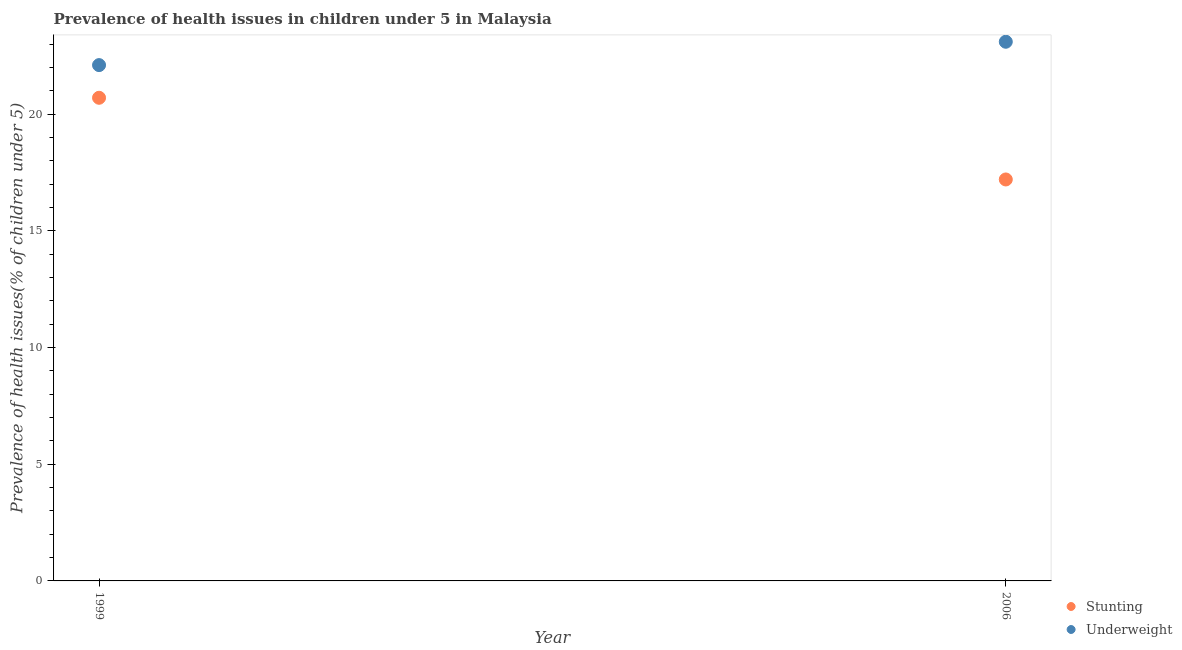How many different coloured dotlines are there?
Offer a terse response. 2. Is the number of dotlines equal to the number of legend labels?
Your response must be concise. Yes. What is the percentage of underweight children in 2006?
Offer a terse response. 23.1. Across all years, what is the maximum percentage of underweight children?
Ensure brevity in your answer.  23.1. Across all years, what is the minimum percentage of stunted children?
Give a very brief answer. 17.2. In which year was the percentage of underweight children maximum?
Provide a short and direct response. 2006. What is the total percentage of stunted children in the graph?
Your response must be concise. 37.9. What is the difference between the percentage of underweight children in 1999 and that in 2006?
Make the answer very short. -1. What is the difference between the percentage of stunted children in 2006 and the percentage of underweight children in 1999?
Ensure brevity in your answer.  -4.9. What is the average percentage of stunted children per year?
Offer a very short reply. 18.95. In the year 1999, what is the difference between the percentage of underweight children and percentage of stunted children?
Offer a very short reply. 1.4. In how many years, is the percentage of stunted children greater than 8 %?
Provide a succinct answer. 2. What is the ratio of the percentage of stunted children in 1999 to that in 2006?
Provide a short and direct response. 1.2. Is the percentage of stunted children in 1999 less than that in 2006?
Make the answer very short. No. In how many years, is the percentage of underweight children greater than the average percentage of underweight children taken over all years?
Offer a very short reply. 1. How many dotlines are there?
Provide a succinct answer. 2. Are the values on the major ticks of Y-axis written in scientific E-notation?
Your response must be concise. No. Does the graph contain grids?
Offer a terse response. No. Where does the legend appear in the graph?
Offer a terse response. Bottom right. How many legend labels are there?
Offer a very short reply. 2. How are the legend labels stacked?
Your answer should be very brief. Vertical. What is the title of the graph?
Your response must be concise. Prevalence of health issues in children under 5 in Malaysia. What is the label or title of the Y-axis?
Your response must be concise. Prevalence of health issues(% of children under 5). What is the Prevalence of health issues(% of children under 5) in Stunting in 1999?
Provide a short and direct response. 20.7. What is the Prevalence of health issues(% of children under 5) in Underweight in 1999?
Ensure brevity in your answer.  22.1. What is the Prevalence of health issues(% of children under 5) of Stunting in 2006?
Provide a succinct answer. 17.2. What is the Prevalence of health issues(% of children under 5) in Underweight in 2006?
Offer a terse response. 23.1. Across all years, what is the maximum Prevalence of health issues(% of children under 5) of Stunting?
Make the answer very short. 20.7. Across all years, what is the maximum Prevalence of health issues(% of children under 5) in Underweight?
Provide a short and direct response. 23.1. Across all years, what is the minimum Prevalence of health issues(% of children under 5) in Stunting?
Make the answer very short. 17.2. Across all years, what is the minimum Prevalence of health issues(% of children under 5) of Underweight?
Your answer should be very brief. 22.1. What is the total Prevalence of health issues(% of children under 5) of Stunting in the graph?
Provide a succinct answer. 37.9. What is the total Prevalence of health issues(% of children under 5) of Underweight in the graph?
Your answer should be compact. 45.2. What is the difference between the Prevalence of health issues(% of children under 5) in Underweight in 1999 and that in 2006?
Make the answer very short. -1. What is the average Prevalence of health issues(% of children under 5) of Stunting per year?
Provide a short and direct response. 18.95. What is the average Prevalence of health issues(% of children under 5) of Underweight per year?
Make the answer very short. 22.6. In the year 2006, what is the difference between the Prevalence of health issues(% of children under 5) in Stunting and Prevalence of health issues(% of children under 5) in Underweight?
Give a very brief answer. -5.9. What is the ratio of the Prevalence of health issues(% of children under 5) of Stunting in 1999 to that in 2006?
Your answer should be very brief. 1.2. What is the ratio of the Prevalence of health issues(% of children under 5) of Underweight in 1999 to that in 2006?
Offer a very short reply. 0.96. What is the difference between the highest and the second highest Prevalence of health issues(% of children under 5) in Stunting?
Provide a short and direct response. 3.5. What is the difference between the highest and the second highest Prevalence of health issues(% of children under 5) in Underweight?
Provide a short and direct response. 1. What is the difference between the highest and the lowest Prevalence of health issues(% of children under 5) in Underweight?
Provide a short and direct response. 1. 